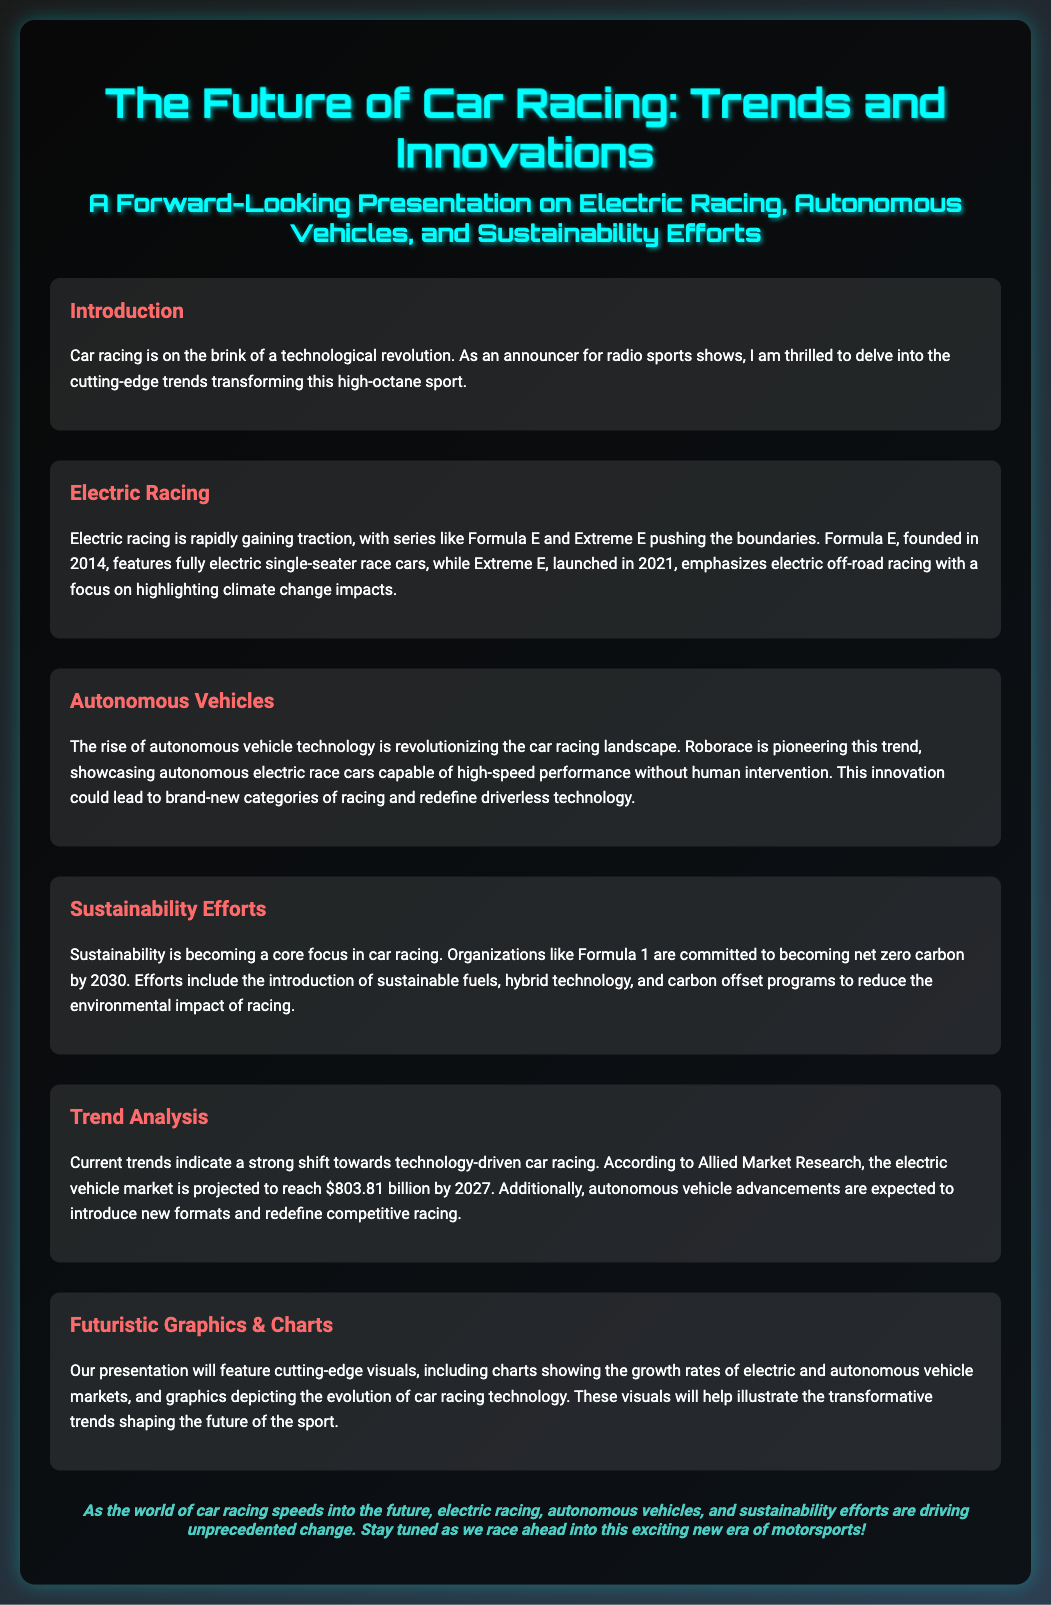What is the title of the presentation? The title of the presentation is bolded at the top of the document.
Answer: The Future of Car Racing: Trends and Innovations When was Formula E founded? The founding year of Formula E is clearly mentioned in the section discussing electric racing.
Answer: 2014 What goal has Formula 1 set for 2030? The sustainability efforts section states a specific commitment from Formula 1.
Answer: Net zero carbon Which series emphasizes electric off-road racing? The document specifies the focus of one of the electric racing series in the relevant section.
Answer: Extreme E What is projected for the electric vehicle market by 2027? The trend analysis section provides a significant market projection figure.
Answer: $803.81 billion What type of vehicles does Roborace showcase? This information is detailed in the section about autonomous vehicles.
Answer: Autonomous electric race cars Which technology is expected to redefine competitive racing? The reasoning involves understanding what innovations are discussed in the autonomous vehicle section of the document.
Answer: Autonomous vehicle advancements What kind of visuals will accompany the presentation? The futuristic graphics section mentions the types of visuals included in the presentation.
Answer: Charts and graphics What date does the presentation focus on? This is a specific element of the document related to the future trends discussed.
Answer: Future 